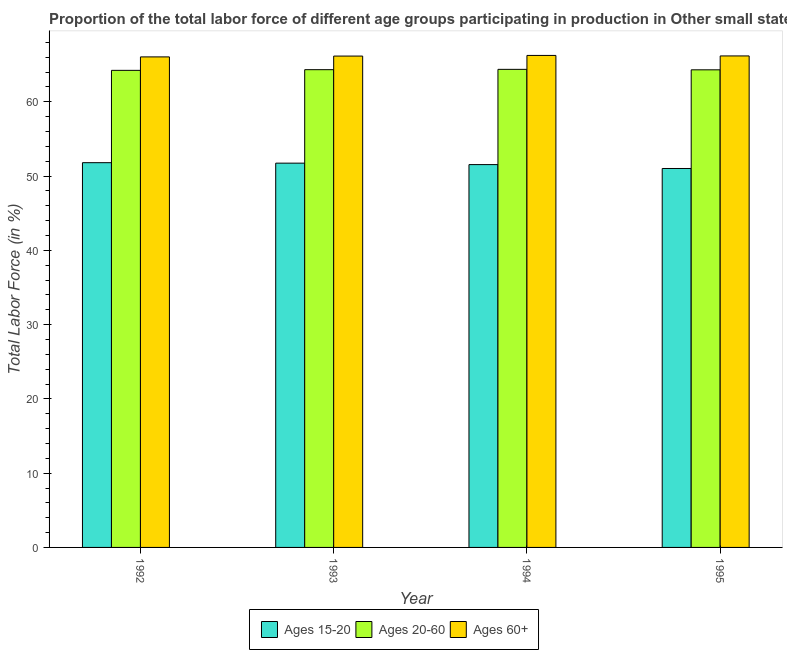Are the number of bars on each tick of the X-axis equal?
Your response must be concise. Yes. How many bars are there on the 3rd tick from the left?
Offer a terse response. 3. How many bars are there on the 4th tick from the right?
Ensure brevity in your answer.  3. What is the label of the 1st group of bars from the left?
Your response must be concise. 1992. In how many cases, is the number of bars for a given year not equal to the number of legend labels?
Ensure brevity in your answer.  0. What is the percentage of labor force within the age group 15-20 in 1993?
Ensure brevity in your answer.  51.74. Across all years, what is the maximum percentage of labor force above age 60?
Your response must be concise. 66.25. Across all years, what is the minimum percentage of labor force above age 60?
Your answer should be very brief. 66.05. In which year was the percentage of labor force within the age group 15-20 maximum?
Provide a short and direct response. 1992. In which year was the percentage of labor force above age 60 minimum?
Make the answer very short. 1992. What is the total percentage of labor force above age 60 in the graph?
Offer a very short reply. 264.65. What is the difference between the percentage of labor force within the age group 20-60 in 1992 and that in 1995?
Your answer should be compact. -0.07. What is the difference between the percentage of labor force above age 60 in 1995 and the percentage of labor force within the age group 20-60 in 1994?
Your answer should be compact. -0.07. What is the average percentage of labor force within the age group 15-20 per year?
Your answer should be very brief. 51.53. In the year 1993, what is the difference between the percentage of labor force within the age group 15-20 and percentage of labor force within the age group 20-60?
Ensure brevity in your answer.  0. In how many years, is the percentage of labor force above age 60 greater than 52 %?
Keep it short and to the point. 4. What is the ratio of the percentage of labor force within the age group 20-60 in 1993 to that in 1995?
Ensure brevity in your answer.  1. What is the difference between the highest and the second highest percentage of labor force within the age group 20-60?
Provide a short and direct response. 0.04. What is the difference between the highest and the lowest percentage of labor force within the age group 20-60?
Ensure brevity in your answer.  0.13. Is the sum of the percentage of labor force within the age group 15-20 in 1992 and 1994 greater than the maximum percentage of labor force above age 60 across all years?
Give a very brief answer. Yes. What does the 3rd bar from the left in 1994 represents?
Ensure brevity in your answer.  Ages 60+. What does the 3rd bar from the right in 1994 represents?
Your response must be concise. Ages 15-20. How many bars are there?
Provide a short and direct response. 12. Are all the bars in the graph horizontal?
Your answer should be compact. No. What is the difference between two consecutive major ticks on the Y-axis?
Offer a terse response. 10. Does the graph contain any zero values?
Make the answer very short. No. Where does the legend appear in the graph?
Give a very brief answer. Bottom center. How many legend labels are there?
Provide a short and direct response. 3. What is the title of the graph?
Ensure brevity in your answer.  Proportion of the total labor force of different age groups participating in production in Other small states. What is the label or title of the X-axis?
Make the answer very short. Year. What is the Total Labor Force (in %) in Ages 15-20 in 1992?
Make the answer very short. 51.81. What is the Total Labor Force (in %) in Ages 20-60 in 1992?
Your response must be concise. 64.24. What is the Total Labor Force (in %) of Ages 60+ in 1992?
Provide a short and direct response. 66.05. What is the Total Labor Force (in %) in Ages 15-20 in 1993?
Your answer should be very brief. 51.74. What is the Total Labor Force (in %) of Ages 20-60 in 1993?
Make the answer very short. 64.33. What is the Total Labor Force (in %) of Ages 60+ in 1993?
Offer a very short reply. 66.16. What is the Total Labor Force (in %) in Ages 15-20 in 1994?
Provide a short and direct response. 51.55. What is the Total Labor Force (in %) of Ages 20-60 in 1994?
Offer a very short reply. 64.37. What is the Total Labor Force (in %) of Ages 60+ in 1994?
Your answer should be compact. 66.25. What is the Total Labor Force (in %) of Ages 15-20 in 1995?
Offer a terse response. 51.03. What is the Total Labor Force (in %) of Ages 20-60 in 1995?
Give a very brief answer. 64.31. What is the Total Labor Force (in %) in Ages 60+ in 1995?
Give a very brief answer. 66.18. Across all years, what is the maximum Total Labor Force (in %) in Ages 15-20?
Your response must be concise. 51.81. Across all years, what is the maximum Total Labor Force (in %) in Ages 20-60?
Give a very brief answer. 64.37. Across all years, what is the maximum Total Labor Force (in %) in Ages 60+?
Make the answer very short. 66.25. Across all years, what is the minimum Total Labor Force (in %) in Ages 15-20?
Provide a succinct answer. 51.03. Across all years, what is the minimum Total Labor Force (in %) in Ages 20-60?
Ensure brevity in your answer.  64.24. Across all years, what is the minimum Total Labor Force (in %) in Ages 60+?
Your answer should be very brief. 66.05. What is the total Total Labor Force (in %) of Ages 15-20 in the graph?
Your response must be concise. 206.13. What is the total Total Labor Force (in %) in Ages 20-60 in the graph?
Provide a succinct answer. 257.26. What is the total Total Labor Force (in %) of Ages 60+ in the graph?
Make the answer very short. 264.65. What is the difference between the Total Labor Force (in %) of Ages 15-20 in 1992 and that in 1993?
Your response must be concise. 0.06. What is the difference between the Total Labor Force (in %) of Ages 20-60 in 1992 and that in 1993?
Make the answer very short. -0.09. What is the difference between the Total Labor Force (in %) of Ages 60+ in 1992 and that in 1993?
Ensure brevity in your answer.  -0.11. What is the difference between the Total Labor Force (in %) in Ages 15-20 in 1992 and that in 1994?
Your response must be concise. 0.26. What is the difference between the Total Labor Force (in %) of Ages 20-60 in 1992 and that in 1994?
Give a very brief answer. -0.13. What is the difference between the Total Labor Force (in %) of Ages 60+ in 1992 and that in 1994?
Make the answer very short. -0.2. What is the difference between the Total Labor Force (in %) of Ages 15-20 in 1992 and that in 1995?
Ensure brevity in your answer.  0.78. What is the difference between the Total Labor Force (in %) of Ages 20-60 in 1992 and that in 1995?
Provide a short and direct response. -0.07. What is the difference between the Total Labor Force (in %) in Ages 60+ in 1992 and that in 1995?
Your answer should be very brief. -0.13. What is the difference between the Total Labor Force (in %) in Ages 15-20 in 1993 and that in 1994?
Your response must be concise. 0.19. What is the difference between the Total Labor Force (in %) of Ages 20-60 in 1993 and that in 1994?
Make the answer very short. -0.04. What is the difference between the Total Labor Force (in %) in Ages 60+ in 1993 and that in 1994?
Make the answer very short. -0.09. What is the difference between the Total Labor Force (in %) in Ages 15-20 in 1993 and that in 1995?
Offer a terse response. 0.72. What is the difference between the Total Labor Force (in %) in Ages 20-60 in 1993 and that in 1995?
Make the answer very short. 0.02. What is the difference between the Total Labor Force (in %) in Ages 60+ in 1993 and that in 1995?
Give a very brief answer. -0.02. What is the difference between the Total Labor Force (in %) in Ages 15-20 in 1994 and that in 1995?
Give a very brief answer. 0.52. What is the difference between the Total Labor Force (in %) in Ages 20-60 in 1994 and that in 1995?
Keep it short and to the point. 0.06. What is the difference between the Total Labor Force (in %) of Ages 60+ in 1994 and that in 1995?
Make the answer very short. 0.07. What is the difference between the Total Labor Force (in %) of Ages 15-20 in 1992 and the Total Labor Force (in %) of Ages 20-60 in 1993?
Your answer should be compact. -12.52. What is the difference between the Total Labor Force (in %) in Ages 15-20 in 1992 and the Total Labor Force (in %) in Ages 60+ in 1993?
Make the answer very short. -14.36. What is the difference between the Total Labor Force (in %) of Ages 20-60 in 1992 and the Total Labor Force (in %) of Ages 60+ in 1993?
Provide a short and direct response. -1.92. What is the difference between the Total Labor Force (in %) of Ages 15-20 in 1992 and the Total Labor Force (in %) of Ages 20-60 in 1994?
Your response must be concise. -12.57. What is the difference between the Total Labor Force (in %) of Ages 15-20 in 1992 and the Total Labor Force (in %) of Ages 60+ in 1994?
Your answer should be compact. -14.44. What is the difference between the Total Labor Force (in %) in Ages 20-60 in 1992 and the Total Labor Force (in %) in Ages 60+ in 1994?
Provide a short and direct response. -2.01. What is the difference between the Total Labor Force (in %) in Ages 15-20 in 1992 and the Total Labor Force (in %) in Ages 20-60 in 1995?
Give a very brief answer. -12.5. What is the difference between the Total Labor Force (in %) of Ages 15-20 in 1992 and the Total Labor Force (in %) of Ages 60+ in 1995?
Offer a terse response. -14.37. What is the difference between the Total Labor Force (in %) in Ages 20-60 in 1992 and the Total Labor Force (in %) in Ages 60+ in 1995?
Your answer should be compact. -1.94. What is the difference between the Total Labor Force (in %) in Ages 15-20 in 1993 and the Total Labor Force (in %) in Ages 20-60 in 1994?
Ensure brevity in your answer.  -12.63. What is the difference between the Total Labor Force (in %) of Ages 15-20 in 1993 and the Total Labor Force (in %) of Ages 60+ in 1994?
Your answer should be very brief. -14.51. What is the difference between the Total Labor Force (in %) in Ages 20-60 in 1993 and the Total Labor Force (in %) in Ages 60+ in 1994?
Provide a short and direct response. -1.92. What is the difference between the Total Labor Force (in %) in Ages 15-20 in 1993 and the Total Labor Force (in %) in Ages 20-60 in 1995?
Your response must be concise. -12.57. What is the difference between the Total Labor Force (in %) in Ages 15-20 in 1993 and the Total Labor Force (in %) in Ages 60+ in 1995?
Your answer should be very brief. -14.44. What is the difference between the Total Labor Force (in %) of Ages 20-60 in 1993 and the Total Labor Force (in %) of Ages 60+ in 1995?
Keep it short and to the point. -1.85. What is the difference between the Total Labor Force (in %) in Ages 15-20 in 1994 and the Total Labor Force (in %) in Ages 20-60 in 1995?
Your answer should be compact. -12.76. What is the difference between the Total Labor Force (in %) of Ages 15-20 in 1994 and the Total Labor Force (in %) of Ages 60+ in 1995?
Ensure brevity in your answer.  -14.63. What is the difference between the Total Labor Force (in %) of Ages 20-60 in 1994 and the Total Labor Force (in %) of Ages 60+ in 1995?
Provide a short and direct response. -1.81. What is the average Total Labor Force (in %) of Ages 15-20 per year?
Your answer should be very brief. 51.53. What is the average Total Labor Force (in %) of Ages 20-60 per year?
Give a very brief answer. 64.31. What is the average Total Labor Force (in %) of Ages 60+ per year?
Offer a very short reply. 66.16. In the year 1992, what is the difference between the Total Labor Force (in %) in Ages 15-20 and Total Labor Force (in %) in Ages 20-60?
Offer a very short reply. -12.43. In the year 1992, what is the difference between the Total Labor Force (in %) in Ages 15-20 and Total Labor Force (in %) in Ages 60+?
Offer a very short reply. -14.24. In the year 1992, what is the difference between the Total Labor Force (in %) in Ages 20-60 and Total Labor Force (in %) in Ages 60+?
Your answer should be very brief. -1.81. In the year 1993, what is the difference between the Total Labor Force (in %) of Ages 15-20 and Total Labor Force (in %) of Ages 20-60?
Keep it short and to the point. -12.59. In the year 1993, what is the difference between the Total Labor Force (in %) in Ages 15-20 and Total Labor Force (in %) in Ages 60+?
Your answer should be compact. -14.42. In the year 1993, what is the difference between the Total Labor Force (in %) in Ages 20-60 and Total Labor Force (in %) in Ages 60+?
Provide a short and direct response. -1.83. In the year 1994, what is the difference between the Total Labor Force (in %) in Ages 15-20 and Total Labor Force (in %) in Ages 20-60?
Give a very brief answer. -12.82. In the year 1994, what is the difference between the Total Labor Force (in %) of Ages 15-20 and Total Labor Force (in %) of Ages 60+?
Your answer should be very brief. -14.7. In the year 1994, what is the difference between the Total Labor Force (in %) of Ages 20-60 and Total Labor Force (in %) of Ages 60+?
Your answer should be compact. -1.88. In the year 1995, what is the difference between the Total Labor Force (in %) in Ages 15-20 and Total Labor Force (in %) in Ages 20-60?
Offer a terse response. -13.29. In the year 1995, what is the difference between the Total Labor Force (in %) of Ages 15-20 and Total Labor Force (in %) of Ages 60+?
Provide a succinct answer. -15.16. In the year 1995, what is the difference between the Total Labor Force (in %) of Ages 20-60 and Total Labor Force (in %) of Ages 60+?
Your answer should be very brief. -1.87. What is the ratio of the Total Labor Force (in %) of Ages 20-60 in 1992 to that in 1993?
Your answer should be compact. 1. What is the ratio of the Total Labor Force (in %) of Ages 15-20 in 1992 to that in 1995?
Offer a terse response. 1.02. What is the ratio of the Total Labor Force (in %) of Ages 60+ in 1992 to that in 1995?
Your response must be concise. 1. What is the ratio of the Total Labor Force (in %) of Ages 60+ in 1993 to that in 1994?
Ensure brevity in your answer.  1. What is the ratio of the Total Labor Force (in %) in Ages 15-20 in 1993 to that in 1995?
Give a very brief answer. 1.01. What is the ratio of the Total Labor Force (in %) in Ages 15-20 in 1994 to that in 1995?
Provide a short and direct response. 1.01. What is the ratio of the Total Labor Force (in %) in Ages 20-60 in 1994 to that in 1995?
Provide a short and direct response. 1. What is the difference between the highest and the second highest Total Labor Force (in %) in Ages 15-20?
Make the answer very short. 0.06. What is the difference between the highest and the second highest Total Labor Force (in %) in Ages 20-60?
Ensure brevity in your answer.  0.04. What is the difference between the highest and the second highest Total Labor Force (in %) of Ages 60+?
Make the answer very short. 0.07. What is the difference between the highest and the lowest Total Labor Force (in %) of Ages 15-20?
Provide a succinct answer. 0.78. What is the difference between the highest and the lowest Total Labor Force (in %) of Ages 20-60?
Offer a terse response. 0.13. What is the difference between the highest and the lowest Total Labor Force (in %) of Ages 60+?
Your response must be concise. 0.2. 